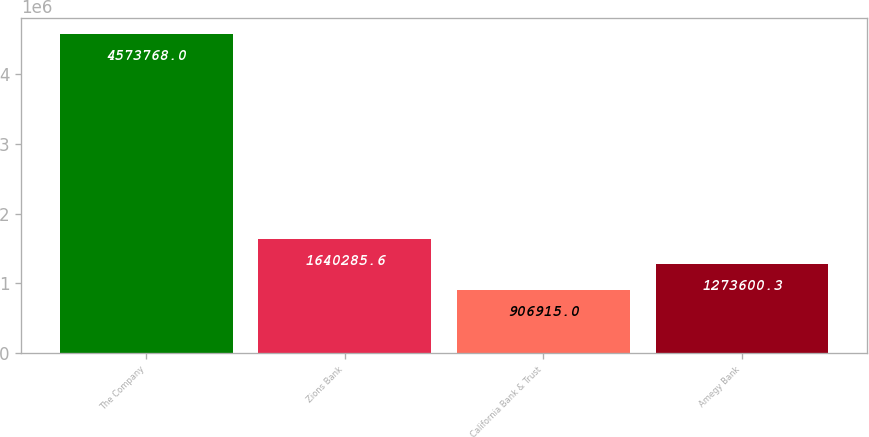<chart> <loc_0><loc_0><loc_500><loc_500><bar_chart><fcel>The Company<fcel>Zions Bank<fcel>California Bank & Trust<fcel>Amegy Bank<nl><fcel>4.57377e+06<fcel>1.64029e+06<fcel>906915<fcel>1.2736e+06<nl></chart> 